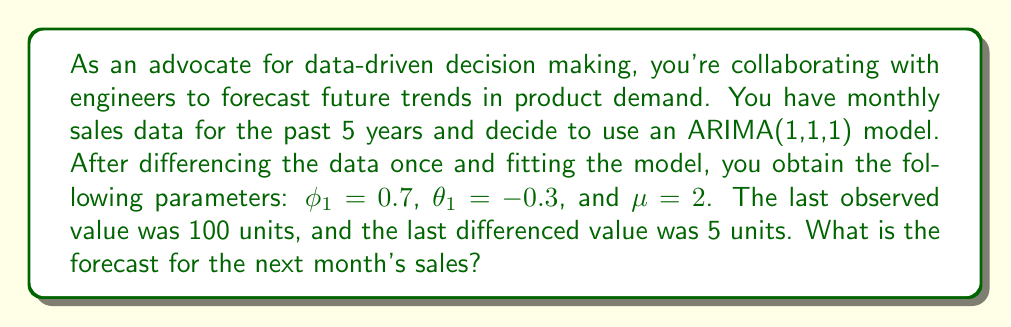Can you solve this math problem? To solve this problem, we'll use the ARIMA(1,1,1) model equation and work through it step-by-step:

1) The general form of an ARIMA(1,1,1) model is:

   $$(1-\phi_1 B)(1-B)y_t = \mu + (1+\theta_1 B)\epsilon_t$$

   where $B$ is the backshift operator.

2) For forecasting one step ahead, we set all future error terms to zero:

   $$(1-\phi_1 B)(1-B)y_{t+1} = \mu$$

3) Expanding this equation:

   $$y_{t+1} - (1+\phi_1)y_t + \phi_1 y_{t-1} = \mu$$

4) Rearranging to solve for $y_{t+1}$:

   $$y_{t+1} = (1+\phi_1)y_t - \phi_1 y_{t-1} + \mu$$

5) We know that $\phi_1 = 0.7$ and $\mu = 2$. We also know that $y_t = 100$ (the last observed value).

6) To find $y_{t-1}$, we use the information about the last differenced value:

   $$y_t - y_{t-1} = 5$$
   $$100 - y_{t-1} = 5$$
   $$y_{t-1} = 95$$

7) Now we can plug all these values into our equation:

   $$y_{t+1} = (1+0.7)(100) - 0.7(95) + 2$$

8) Calculating:

   $$y_{t+1} = 170 - 66.5 + 2 = 105.5$$

Therefore, the forecast for next month's sales is 105.5 units.
Answer: 105.5 units 